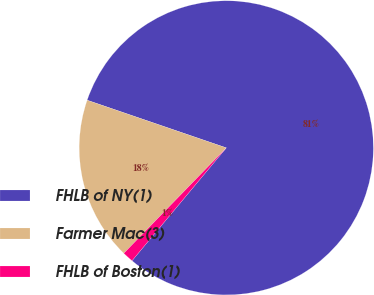Convert chart. <chart><loc_0><loc_0><loc_500><loc_500><pie_chart><fcel>FHLB of NY(1)<fcel>Farmer Mac(3)<fcel>FHLB of Boston(1)<nl><fcel>80.82%<fcel>17.98%<fcel>1.2%<nl></chart> 